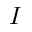<formula> <loc_0><loc_0><loc_500><loc_500>I</formula> 